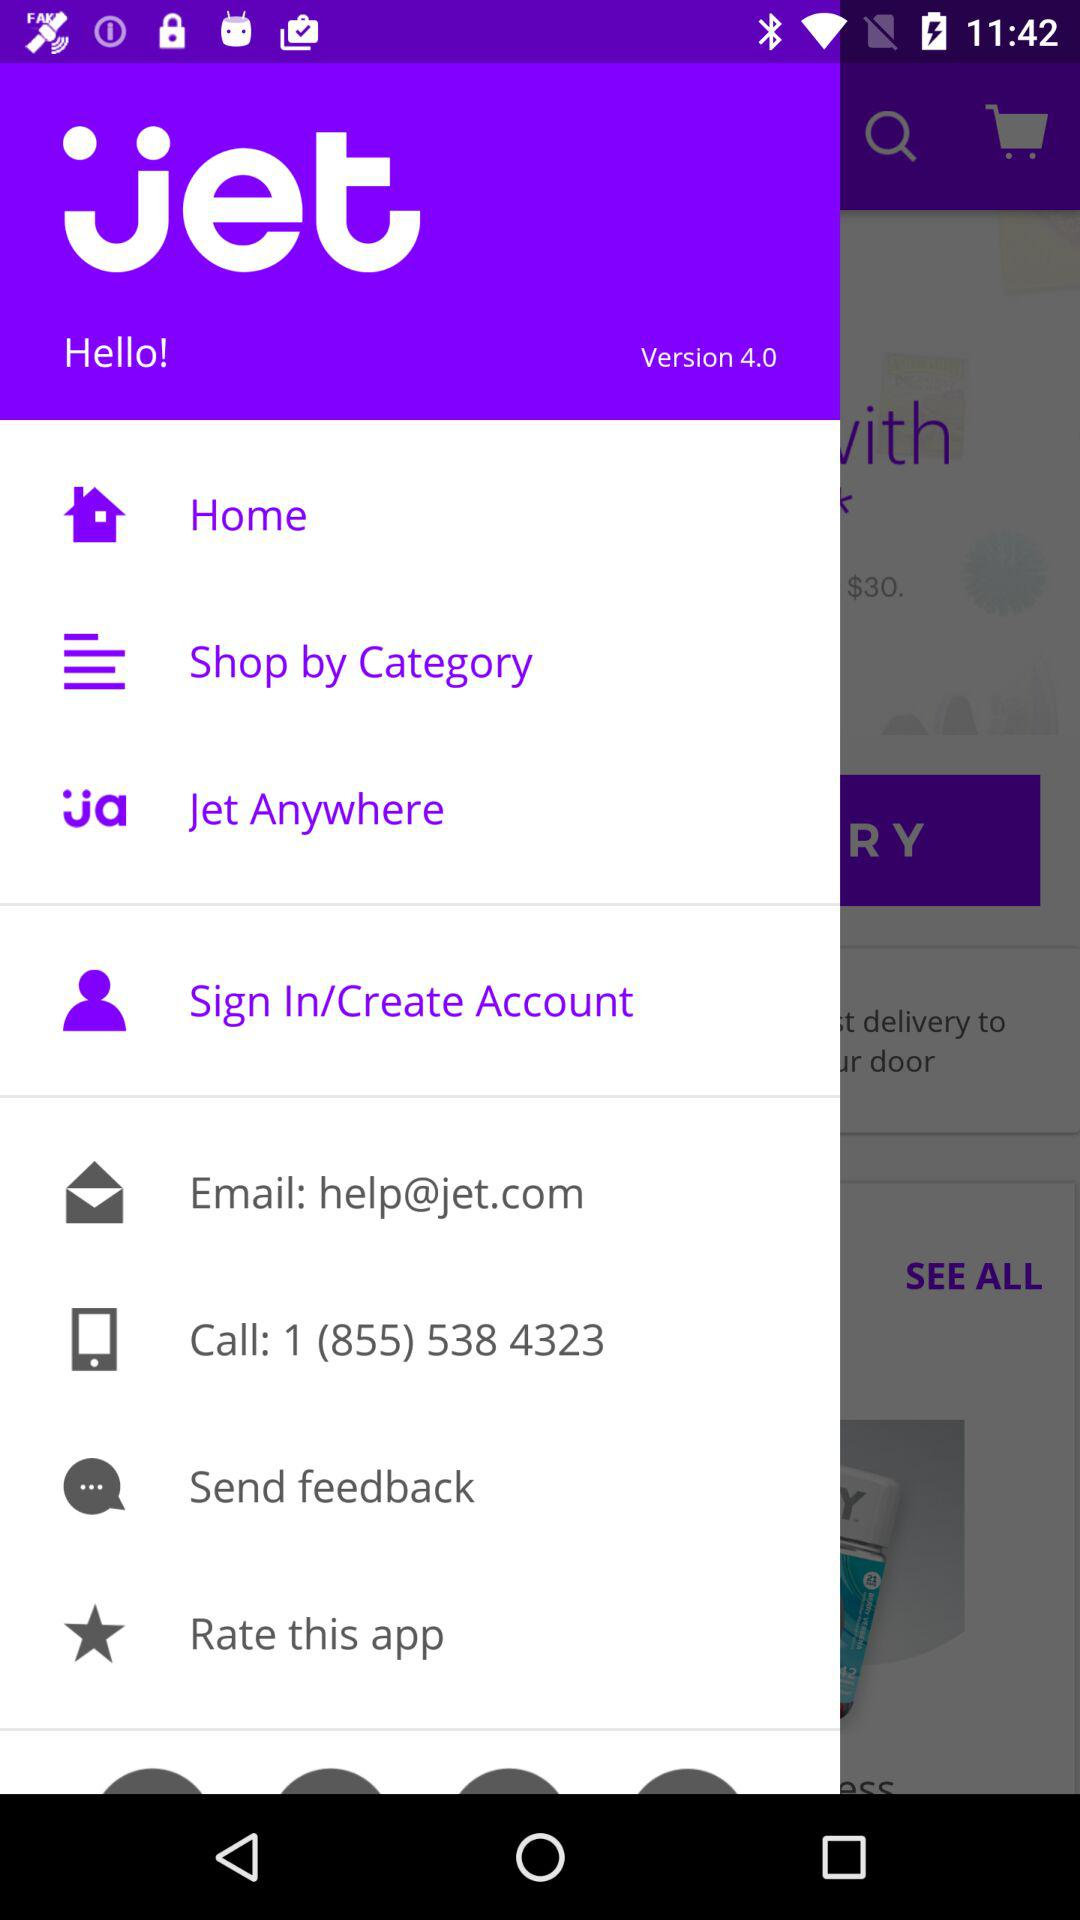What is the contact number? The contact number is 1 (855) 538 4323. 